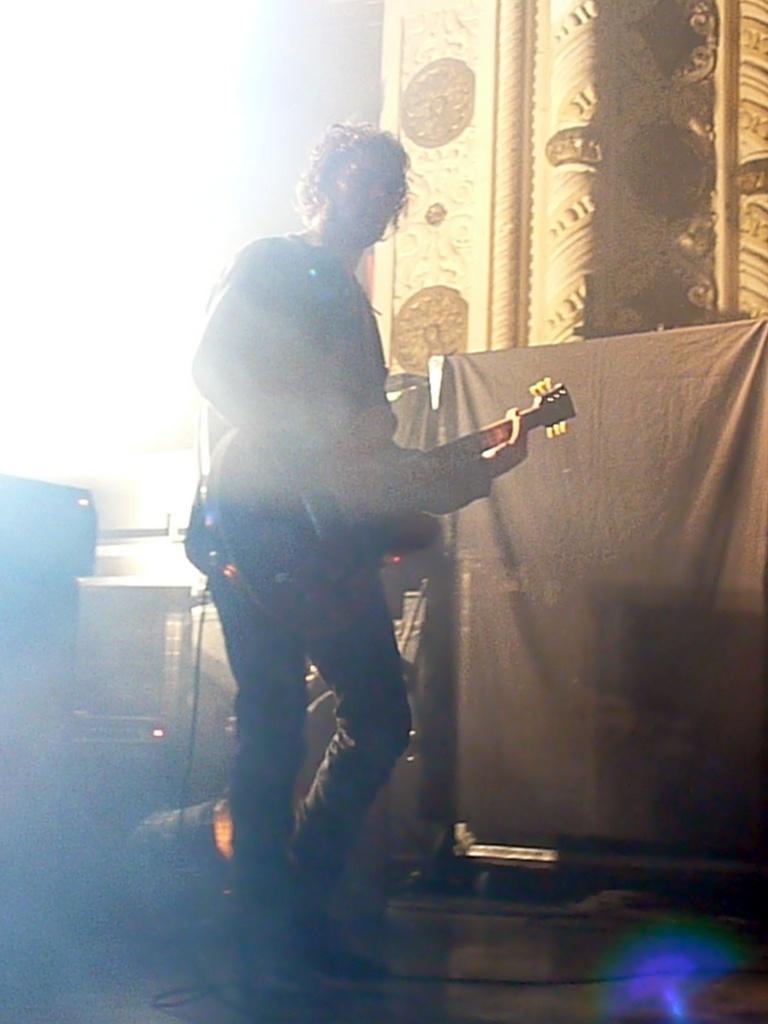In one or two sentences, can you explain what this image depicts? In this picture there is a person standing and playing guitar in his hands and there are few musical instruments behind him and there is a black color cloth in the right corner. 